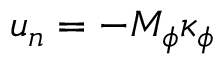<formula> <loc_0><loc_0><loc_500><loc_500>{ u _ { n } } = - { M _ { \phi } } { \kappa _ { \phi } }</formula> 